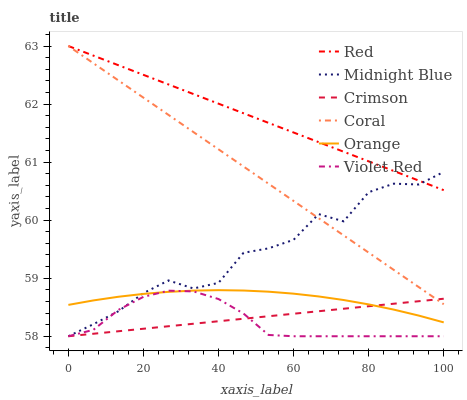Does Midnight Blue have the minimum area under the curve?
Answer yes or no. No. Does Midnight Blue have the maximum area under the curve?
Answer yes or no. No. Is Midnight Blue the smoothest?
Answer yes or no. No. Is Coral the roughest?
Answer yes or no. No. Does Coral have the lowest value?
Answer yes or no. No. Does Midnight Blue have the highest value?
Answer yes or no. No. Is Orange less than Red?
Answer yes or no. Yes. Is Red greater than Orange?
Answer yes or no. Yes. Does Orange intersect Red?
Answer yes or no. No. 